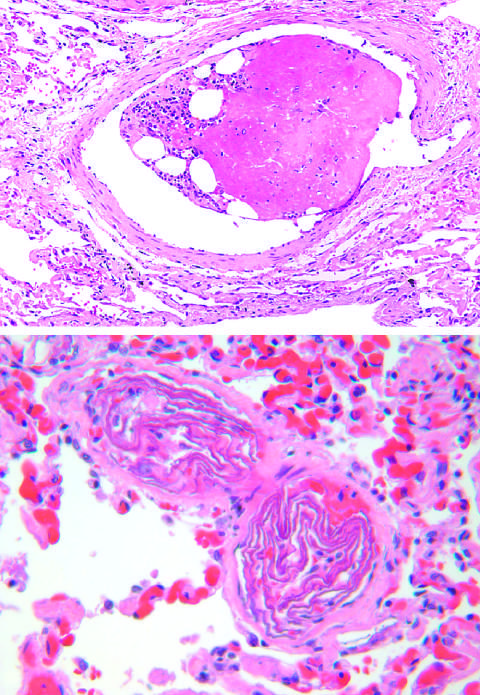what are two small pulmonary arterioles packed with of fetal squamous cells?
Answer the question using a single word or phrase. Laminated swirls 